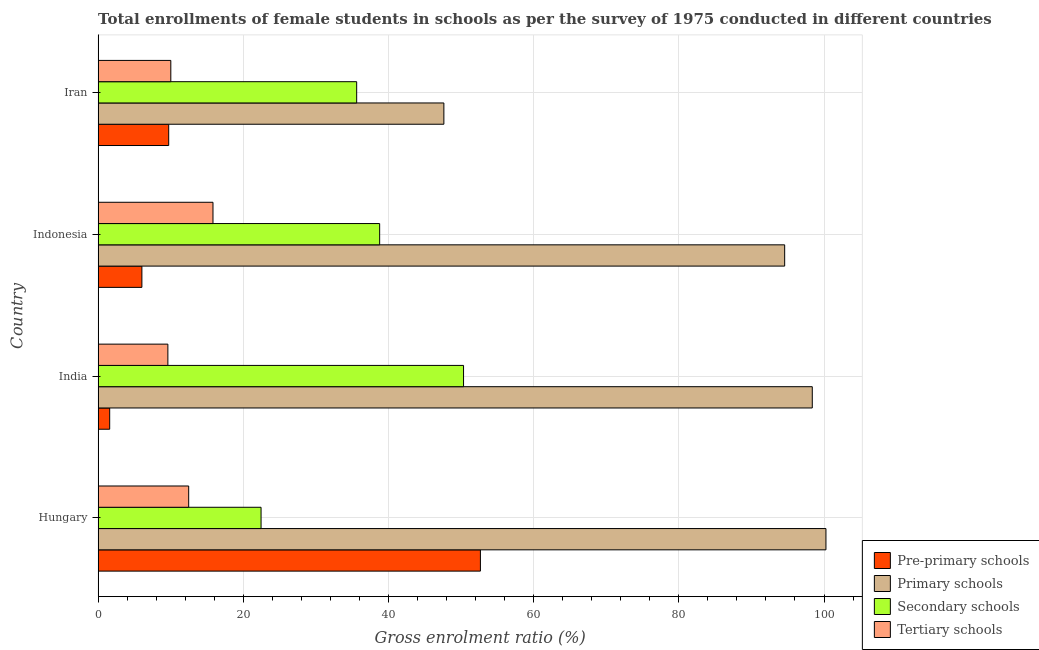How many different coloured bars are there?
Ensure brevity in your answer.  4. How many groups of bars are there?
Provide a short and direct response. 4. Are the number of bars per tick equal to the number of legend labels?
Your response must be concise. Yes. How many bars are there on the 3rd tick from the top?
Your response must be concise. 4. What is the label of the 2nd group of bars from the top?
Keep it short and to the point. Indonesia. What is the gross enrolment ratio(female) in pre-primary schools in India?
Your response must be concise. 1.59. Across all countries, what is the maximum gross enrolment ratio(female) in pre-primary schools?
Your answer should be compact. 52.67. Across all countries, what is the minimum gross enrolment ratio(female) in secondary schools?
Ensure brevity in your answer.  22.45. What is the total gross enrolment ratio(female) in primary schools in the graph?
Provide a succinct answer. 340.87. What is the difference between the gross enrolment ratio(female) in primary schools in India and that in Iran?
Ensure brevity in your answer.  50.75. What is the difference between the gross enrolment ratio(female) in primary schools in Indonesia and the gross enrolment ratio(female) in secondary schools in India?
Ensure brevity in your answer.  44.24. What is the average gross enrolment ratio(female) in primary schools per country?
Ensure brevity in your answer.  85.22. What is the difference between the gross enrolment ratio(female) in pre-primary schools and gross enrolment ratio(female) in tertiary schools in Iran?
Your response must be concise. -0.29. In how many countries, is the gross enrolment ratio(female) in primary schools greater than 24 %?
Provide a succinct answer. 4. What is the ratio of the gross enrolment ratio(female) in secondary schools in Hungary to that in Indonesia?
Make the answer very short. 0.58. Is the gross enrolment ratio(female) in primary schools in Hungary less than that in Iran?
Give a very brief answer. No. What is the difference between the highest and the second highest gross enrolment ratio(female) in tertiary schools?
Your answer should be very brief. 3.35. What is the difference between the highest and the lowest gross enrolment ratio(female) in pre-primary schools?
Offer a very short reply. 51.07. What does the 3rd bar from the top in India represents?
Your response must be concise. Primary schools. What does the 4th bar from the bottom in Hungary represents?
Your answer should be very brief. Tertiary schools. How many bars are there?
Offer a terse response. 16. Are all the bars in the graph horizontal?
Your answer should be compact. Yes. Does the graph contain any zero values?
Ensure brevity in your answer.  No. How are the legend labels stacked?
Make the answer very short. Vertical. What is the title of the graph?
Your response must be concise. Total enrollments of female students in schools as per the survey of 1975 conducted in different countries. Does "Permanent crop land" appear as one of the legend labels in the graph?
Your answer should be compact. No. What is the label or title of the X-axis?
Offer a terse response. Gross enrolment ratio (%). What is the Gross enrolment ratio (%) of Pre-primary schools in Hungary?
Offer a terse response. 52.67. What is the Gross enrolment ratio (%) of Primary schools in Hungary?
Your response must be concise. 100.27. What is the Gross enrolment ratio (%) in Secondary schools in Hungary?
Keep it short and to the point. 22.45. What is the Gross enrolment ratio (%) in Tertiary schools in Hungary?
Offer a terse response. 12.48. What is the Gross enrolment ratio (%) of Pre-primary schools in India?
Your answer should be compact. 1.59. What is the Gross enrolment ratio (%) of Primary schools in India?
Provide a short and direct response. 98.39. What is the Gross enrolment ratio (%) of Secondary schools in India?
Offer a very short reply. 50.34. What is the Gross enrolment ratio (%) of Tertiary schools in India?
Ensure brevity in your answer.  9.61. What is the Gross enrolment ratio (%) of Pre-primary schools in Indonesia?
Ensure brevity in your answer.  6.03. What is the Gross enrolment ratio (%) in Primary schools in Indonesia?
Make the answer very short. 94.58. What is the Gross enrolment ratio (%) of Secondary schools in Indonesia?
Keep it short and to the point. 38.79. What is the Gross enrolment ratio (%) of Tertiary schools in Indonesia?
Give a very brief answer. 15.83. What is the Gross enrolment ratio (%) of Pre-primary schools in Iran?
Your answer should be very brief. 9.72. What is the Gross enrolment ratio (%) in Primary schools in Iran?
Ensure brevity in your answer.  47.63. What is the Gross enrolment ratio (%) in Secondary schools in Iran?
Keep it short and to the point. 35.62. What is the Gross enrolment ratio (%) of Tertiary schools in Iran?
Make the answer very short. 10.02. Across all countries, what is the maximum Gross enrolment ratio (%) in Pre-primary schools?
Offer a terse response. 52.67. Across all countries, what is the maximum Gross enrolment ratio (%) of Primary schools?
Make the answer very short. 100.27. Across all countries, what is the maximum Gross enrolment ratio (%) in Secondary schools?
Your answer should be very brief. 50.34. Across all countries, what is the maximum Gross enrolment ratio (%) in Tertiary schools?
Provide a short and direct response. 15.83. Across all countries, what is the minimum Gross enrolment ratio (%) in Pre-primary schools?
Your answer should be very brief. 1.59. Across all countries, what is the minimum Gross enrolment ratio (%) of Primary schools?
Give a very brief answer. 47.63. Across all countries, what is the minimum Gross enrolment ratio (%) in Secondary schools?
Give a very brief answer. 22.45. Across all countries, what is the minimum Gross enrolment ratio (%) of Tertiary schools?
Ensure brevity in your answer.  9.61. What is the total Gross enrolment ratio (%) in Pre-primary schools in the graph?
Your answer should be very brief. 70.01. What is the total Gross enrolment ratio (%) in Primary schools in the graph?
Give a very brief answer. 340.87. What is the total Gross enrolment ratio (%) of Secondary schools in the graph?
Your response must be concise. 147.2. What is the total Gross enrolment ratio (%) of Tertiary schools in the graph?
Provide a short and direct response. 47.93. What is the difference between the Gross enrolment ratio (%) of Pre-primary schools in Hungary and that in India?
Offer a very short reply. 51.07. What is the difference between the Gross enrolment ratio (%) of Primary schools in Hungary and that in India?
Provide a succinct answer. 1.88. What is the difference between the Gross enrolment ratio (%) of Secondary schools in Hungary and that in India?
Your answer should be compact. -27.9. What is the difference between the Gross enrolment ratio (%) in Tertiary schools in Hungary and that in India?
Ensure brevity in your answer.  2.87. What is the difference between the Gross enrolment ratio (%) of Pre-primary schools in Hungary and that in Indonesia?
Give a very brief answer. 46.64. What is the difference between the Gross enrolment ratio (%) of Primary schools in Hungary and that in Indonesia?
Your answer should be very brief. 5.69. What is the difference between the Gross enrolment ratio (%) of Secondary schools in Hungary and that in Indonesia?
Give a very brief answer. -16.34. What is the difference between the Gross enrolment ratio (%) in Tertiary schools in Hungary and that in Indonesia?
Keep it short and to the point. -3.35. What is the difference between the Gross enrolment ratio (%) of Pre-primary schools in Hungary and that in Iran?
Provide a short and direct response. 42.94. What is the difference between the Gross enrolment ratio (%) in Primary schools in Hungary and that in Iran?
Give a very brief answer. 52.64. What is the difference between the Gross enrolment ratio (%) in Secondary schools in Hungary and that in Iran?
Keep it short and to the point. -13.17. What is the difference between the Gross enrolment ratio (%) in Tertiary schools in Hungary and that in Iran?
Provide a succinct answer. 2.46. What is the difference between the Gross enrolment ratio (%) in Pre-primary schools in India and that in Indonesia?
Your answer should be very brief. -4.44. What is the difference between the Gross enrolment ratio (%) in Primary schools in India and that in Indonesia?
Offer a terse response. 3.8. What is the difference between the Gross enrolment ratio (%) in Secondary schools in India and that in Indonesia?
Offer a very short reply. 11.56. What is the difference between the Gross enrolment ratio (%) in Tertiary schools in India and that in Indonesia?
Provide a short and direct response. -6.22. What is the difference between the Gross enrolment ratio (%) in Pre-primary schools in India and that in Iran?
Make the answer very short. -8.13. What is the difference between the Gross enrolment ratio (%) of Primary schools in India and that in Iran?
Provide a succinct answer. 50.75. What is the difference between the Gross enrolment ratio (%) in Secondary schools in India and that in Iran?
Your answer should be compact. 14.72. What is the difference between the Gross enrolment ratio (%) in Tertiary schools in India and that in Iran?
Provide a short and direct response. -0.41. What is the difference between the Gross enrolment ratio (%) of Pre-primary schools in Indonesia and that in Iran?
Provide a succinct answer. -3.69. What is the difference between the Gross enrolment ratio (%) in Primary schools in Indonesia and that in Iran?
Keep it short and to the point. 46.95. What is the difference between the Gross enrolment ratio (%) in Secondary schools in Indonesia and that in Iran?
Offer a very short reply. 3.17. What is the difference between the Gross enrolment ratio (%) in Tertiary schools in Indonesia and that in Iran?
Make the answer very short. 5.81. What is the difference between the Gross enrolment ratio (%) in Pre-primary schools in Hungary and the Gross enrolment ratio (%) in Primary schools in India?
Ensure brevity in your answer.  -45.72. What is the difference between the Gross enrolment ratio (%) in Pre-primary schools in Hungary and the Gross enrolment ratio (%) in Secondary schools in India?
Provide a succinct answer. 2.32. What is the difference between the Gross enrolment ratio (%) in Pre-primary schools in Hungary and the Gross enrolment ratio (%) in Tertiary schools in India?
Your answer should be compact. 43.06. What is the difference between the Gross enrolment ratio (%) in Primary schools in Hungary and the Gross enrolment ratio (%) in Secondary schools in India?
Your answer should be compact. 49.93. What is the difference between the Gross enrolment ratio (%) of Primary schools in Hungary and the Gross enrolment ratio (%) of Tertiary schools in India?
Keep it short and to the point. 90.66. What is the difference between the Gross enrolment ratio (%) of Secondary schools in Hungary and the Gross enrolment ratio (%) of Tertiary schools in India?
Offer a very short reply. 12.84. What is the difference between the Gross enrolment ratio (%) in Pre-primary schools in Hungary and the Gross enrolment ratio (%) in Primary schools in Indonesia?
Your answer should be compact. -41.92. What is the difference between the Gross enrolment ratio (%) of Pre-primary schools in Hungary and the Gross enrolment ratio (%) of Secondary schools in Indonesia?
Provide a succinct answer. 13.88. What is the difference between the Gross enrolment ratio (%) in Pre-primary schools in Hungary and the Gross enrolment ratio (%) in Tertiary schools in Indonesia?
Make the answer very short. 36.84. What is the difference between the Gross enrolment ratio (%) of Primary schools in Hungary and the Gross enrolment ratio (%) of Secondary schools in Indonesia?
Give a very brief answer. 61.48. What is the difference between the Gross enrolment ratio (%) in Primary schools in Hungary and the Gross enrolment ratio (%) in Tertiary schools in Indonesia?
Ensure brevity in your answer.  84.44. What is the difference between the Gross enrolment ratio (%) in Secondary schools in Hungary and the Gross enrolment ratio (%) in Tertiary schools in Indonesia?
Keep it short and to the point. 6.62. What is the difference between the Gross enrolment ratio (%) in Pre-primary schools in Hungary and the Gross enrolment ratio (%) in Primary schools in Iran?
Offer a very short reply. 5.03. What is the difference between the Gross enrolment ratio (%) of Pre-primary schools in Hungary and the Gross enrolment ratio (%) of Secondary schools in Iran?
Offer a terse response. 17.05. What is the difference between the Gross enrolment ratio (%) of Pre-primary schools in Hungary and the Gross enrolment ratio (%) of Tertiary schools in Iran?
Your response must be concise. 42.65. What is the difference between the Gross enrolment ratio (%) in Primary schools in Hungary and the Gross enrolment ratio (%) in Secondary schools in Iran?
Keep it short and to the point. 64.65. What is the difference between the Gross enrolment ratio (%) in Primary schools in Hungary and the Gross enrolment ratio (%) in Tertiary schools in Iran?
Provide a short and direct response. 90.25. What is the difference between the Gross enrolment ratio (%) in Secondary schools in Hungary and the Gross enrolment ratio (%) in Tertiary schools in Iran?
Give a very brief answer. 12.43. What is the difference between the Gross enrolment ratio (%) of Pre-primary schools in India and the Gross enrolment ratio (%) of Primary schools in Indonesia?
Offer a very short reply. -92.99. What is the difference between the Gross enrolment ratio (%) of Pre-primary schools in India and the Gross enrolment ratio (%) of Secondary schools in Indonesia?
Make the answer very short. -37.19. What is the difference between the Gross enrolment ratio (%) in Pre-primary schools in India and the Gross enrolment ratio (%) in Tertiary schools in Indonesia?
Your answer should be compact. -14.23. What is the difference between the Gross enrolment ratio (%) in Primary schools in India and the Gross enrolment ratio (%) in Secondary schools in Indonesia?
Ensure brevity in your answer.  59.6. What is the difference between the Gross enrolment ratio (%) of Primary schools in India and the Gross enrolment ratio (%) of Tertiary schools in Indonesia?
Ensure brevity in your answer.  82.56. What is the difference between the Gross enrolment ratio (%) of Secondary schools in India and the Gross enrolment ratio (%) of Tertiary schools in Indonesia?
Your answer should be very brief. 34.52. What is the difference between the Gross enrolment ratio (%) in Pre-primary schools in India and the Gross enrolment ratio (%) in Primary schools in Iran?
Make the answer very short. -46.04. What is the difference between the Gross enrolment ratio (%) of Pre-primary schools in India and the Gross enrolment ratio (%) of Secondary schools in Iran?
Provide a succinct answer. -34.03. What is the difference between the Gross enrolment ratio (%) of Pre-primary schools in India and the Gross enrolment ratio (%) of Tertiary schools in Iran?
Your response must be concise. -8.42. What is the difference between the Gross enrolment ratio (%) in Primary schools in India and the Gross enrolment ratio (%) in Secondary schools in Iran?
Offer a terse response. 62.77. What is the difference between the Gross enrolment ratio (%) in Primary schools in India and the Gross enrolment ratio (%) in Tertiary schools in Iran?
Keep it short and to the point. 88.37. What is the difference between the Gross enrolment ratio (%) of Secondary schools in India and the Gross enrolment ratio (%) of Tertiary schools in Iran?
Make the answer very short. 40.33. What is the difference between the Gross enrolment ratio (%) of Pre-primary schools in Indonesia and the Gross enrolment ratio (%) of Primary schools in Iran?
Your answer should be compact. -41.6. What is the difference between the Gross enrolment ratio (%) of Pre-primary schools in Indonesia and the Gross enrolment ratio (%) of Secondary schools in Iran?
Offer a very short reply. -29.59. What is the difference between the Gross enrolment ratio (%) in Pre-primary schools in Indonesia and the Gross enrolment ratio (%) in Tertiary schools in Iran?
Your answer should be compact. -3.99. What is the difference between the Gross enrolment ratio (%) of Primary schools in Indonesia and the Gross enrolment ratio (%) of Secondary schools in Iran?
Provide a short and direct response. 58.96. What is the difference between the Gross enrolment ratio (%) in Primary schools in Indonesia and the Gross enrolment ratio (%) in Tertiary schools in Iran?
Provide a succinct answer. 84.57. What is the difference between the Gross enrolment ratio (%) in Secondary schools in Indonesia and the Gross enrolment ratio (%) in Tertiary schools in Iran?
Your response must be concise. 28.77. What is the average Gross enrolment ratio (%) of Pre-primary schools per country?
Provide a succinct answer. 17.5. What is the average Gross enrolment ratio (%) in Primary schools per country?
Your answer should be very brief. 85.22. What is the average Gross enrolment ratio (%) of Secondary schools per country?
Ensure brevity in your answer.  36.8. What is the average Gross enrolment ratio (%) of Tertiary schools per country?
Your response must be concise. 11.98. What is the difference between the Gross enrolment ratio (%) in Pre-primary schools and Gross enrolment ratio (%) in Primary schools in Hungary?
Ensure brevity in your answer.  -47.6. What is the difference between the Gross enrolment ratio (%) in Pre-primary schools and Gross enrolment ratio (%) in Secondary schools in Hungary?
Give a very brief answer. 30.22. What is the difference between the Gross enrolment ratio (%) in Pre-primary schools and Gross enrolment ratio (%) in Tertiary schools in Hungary?
Offer a very short reply. 40.19. What is the difference between the Gross enrolment ratio (%) of Primary schools and Gross enrolment ratio (%) of Secondary schools in Hungary?
Give a very brief answer. 77.82. What is the difference between the Gross enrolment ratio (%) of Primary schools and Gross enrolment ratio (%) of Tertiary schools in Hungary?
Keep it short and to the point. 87.79. What is the difference between the Gross enrolment ratio (%) of Secondary schools and Gross enrolment ratio (%) of Tertiary schools in Hungary?
Ensure brevity in your answer.  9.97. What is the difference between the Gross enrolment ratio (%) of Pre-primary schools and Gross enrolment ratio (%) of Primary schools in India?
Keep it short and to the point. -96.79. What is the difference between the Gross enrolment ratio (%) in Pre-primary schools and Gross enrolment ratio (%) in Secondary schools in India?
Offer a terse response. -48.75. What is the difference between the Gross enrolment ratio (%) of Pre-primary schools and Gross enrolment ratio (%) of Tertiary schools in India?
Your answer should be compact. -8.02. What is the difference between the Gross enrolment ratio (%) of Primary schools and Gross enrolment ratio (%) of Secondary schools in India?
Offer a terse response. 48.04. What is the difference between the Gross enrolment ratio (%) of Primary schools and Gross enrolment ratio (%) of Tertiary schools in India?
Keep it short and to the point. 88.78. What is the difference between the Gross enrolment ratio (%) of Secondary schools and Gross enrolment ratio (%) of Tertiary schools in India?
Offer a terse response. 40.73. What is the difference between the Gross enrolment ratio (%) of Pre-primary schools and Gross enrolment ratio (%) of Primary schools in Indonesia?
Your answer should be compact. -88.55. What is the difference between the Gross enrolment ratio (%) of Pre-primary schools and Gross enrolment ratio (%) of Secondary schools in Indonesia?
Ensure brevity in your answer.  -32.76. What is the difference between the Gross enrolment ratio (%) in Pre-primary schools and Gross enrolment ratio (%) in Tertiary schools in Indonesia?
Your answer should be compact. -9.8. What is the difference between the Gross enrolment ratio (%) of Primary schools and Gross enrolment ratio (%) of Secondary schools in Indonesia?
Offer a terse response. 55.8. What is the difference between the Gross enrolment ratio (%) of Primary schools and Gross enrolment ratio (%) of Tertiary schools in Indonesia?
Offer a terse response. 78.76. What is the difference between the Gross enrolment ratio (%) in Secondary schools and Gross enrolment ratio (%) in Tertiary schools in Indonesia?
Give a very brief answer. 22.96. What is the difference between the Gross enrolment ratio (%) in Pre-primary schools and Gross enrolment ratio (%) in Primary schools in Iran?
Give a very brief answer. -37.91. What is the difference between the Gross enrolment ratio (%) of Pre-primary schools and Gross enrolment ratio (%) of Secondary schools in Iran?
Offer a terse response. -25.9. What is the difference between the Gross enrolment ratio (%) of Pre-primary schools and Gross enrolment ratio (%) of Tertiary schools in Iran?
Provide a short and direct response. -0.29. What is the difference between the Gross enrolment ratio (%) of Primary schools and Gross enrolment ratio (%) of Secondary schools in Iran?
Ensure brevity in your answer.  12.01. What is the difference between the Gross enrolment ratio (%) in Primary schools and Gross enrolment ratio (%) in Tertiary schools in Iran?
Offer a very short reply. 37.62. What is the difference between the Gross enrolment ratio (%) in Secondary schools and Gross enrolment ratio (%) in Tertiary schools in Iran?
Give a very brief answer. 25.6. What is the ratio of the Gross enrolment ratio (%) in Pre-primary schools in Hungary to that in India?
Your answer should be very brief. 33.05. What is the ratio of the Gross enrolment ratio (%) in Primary schools in Hungary to that in India?
Provide a short and direct response. 1.02. What is the ratio of the Gross enrolment ratio (%) in Secondary schools in Hungary to that in India?
Offer a very short reply. 0.45. What is the ratio of the Gross enrolment ratio (%) in Tertiary schools in Hungary to that in India?
Provide a succinct answer. 1.3. What is the ratio of the Gross enrolment ratio (%) in Pre-primary schools in Hungary to that in Indonesia?
Give a very brief answer. 8.73. What is the ratio of the Gross enrolment ratio (%) in Primary schools in Hungary to that in Indonesia?
Give a very brief answer. 1.06. What is the ratio of the Gross enrolment ratio (%) in Secondary schools in Hungary to that in Indonesia?
Offer a very short reply. 0.58. What is the ratio of the Gross enrolment ratio (%) of Tertiary schools in Hungary to that in Indonesia?
Your answer should be compact. 0.79. What is the ratio of the Gross enrolment ratio (%) of Pre-primary schools in Hungary to that in Iran?
Offer a terse response. 5.42. What is the ratio of the Gross enrolment ratio (%) of Primary schools in Hungary to that in Iran?
Provide a succinct answer. 2.11. What is the ratio of the Gross enrolment ratio (%) of Secondary schools in Hungary to that in Iran?
Offer a very short reply. 0.63. What is the ratio of the Gross enrolment ratio (%) in Tertiary schools in Hungary to that in Iran?
Provide a short and direct response. 1.25. What is the ratio of the Gross enrolment ratio (%) of Pre-primary schools in India to that in Indonesia?
Offer a very short reply. 0.26. What is the ratio of the Gross enrolment ratio (%) in Primary schools in India to that in Indonesia?
Provide a short and direct response. 1.04. What is the ratio of the Gross enrolment ratio (%) in Secondary schools in India to that in Indonesia?
Your answer should be very brief. 1.3. What is the ratio of the Gross enrolment ratio (%) in Tertiary schools in India to that in Indonesia?
Provide a short and direct response. 0.61. What is the ratio of the Gross enrolment ratio (%) of Pre-primary schools in India to that in Iran?
Your response must be concise. 0.16. What is the ratio of the Gross enrolment ratio (%) in Primary schools in India to that in Iran?
Offer a terse response. 2.07. What is the ratio of the Gross enrolment ratio (%) of Secondary schools in India to that in Iran?
Your answer should be very brief. 1.41. What is the ratio of the Gross enrolment ratio (%) of Tertiary schools in India to that in Iran?
Keep it short and to the point. 0.96. What is the ratio of the Gross enrolment ratio (%) in Pre-primary schools in Indonesia to that in Iran?
Offer a terse response. 0.62. What is the ratio of the Gross enrolment ratio (%) in Primary schools in Indonesia to that in Iran?
Your response must be concise. 1.99. What is the ratio of the Gross enrolment ratio (%) in Secondary schools in Indonesia to that in Iran?
Your response must be concise. 1.09. What is the ratio of the Gross enrolment ratio (%) in Tertiary schools in Indonesia to that in Iran?
Provide a succinct answer. 1.58. What is the difference between the highest and the second highest Gross enrolment ratio (%) of Pre-primary schools?
Keep it short and to the point. 42.94. What is the difference between the highest and the second highest Gross enrolment ratio (%) of Primary schools?
Offer a very short reply. 1.88. What is the difference between the highest and the second highest Gross enrolment ratio (%) in Secondary schools?
Provide a short and direct response. 11.56. What is the difference between the highest and the second highest Gross enrolment ratio (%) in Tertiary schools?
Provide a succinct answer. 3.35. What is the difference between the highest and the lowest Gross enrolment ratio (%) in Pre-primary schools?
Provide a short and direct response. 51.07. What is the difference between the highest and the lowest Gross enrolment ratio (%) in Primary schools?
Your answer should be compact. 52.64. What is the difference between the highest and the lowest Gross enrolment ratio (%) in Secondary schools?
Make the answer very short. 27.9. What is the difference between the highest and the lowest Gross enrolment ratio (%) of Tertiary schools?
Your answer should be compact. 6.22. 